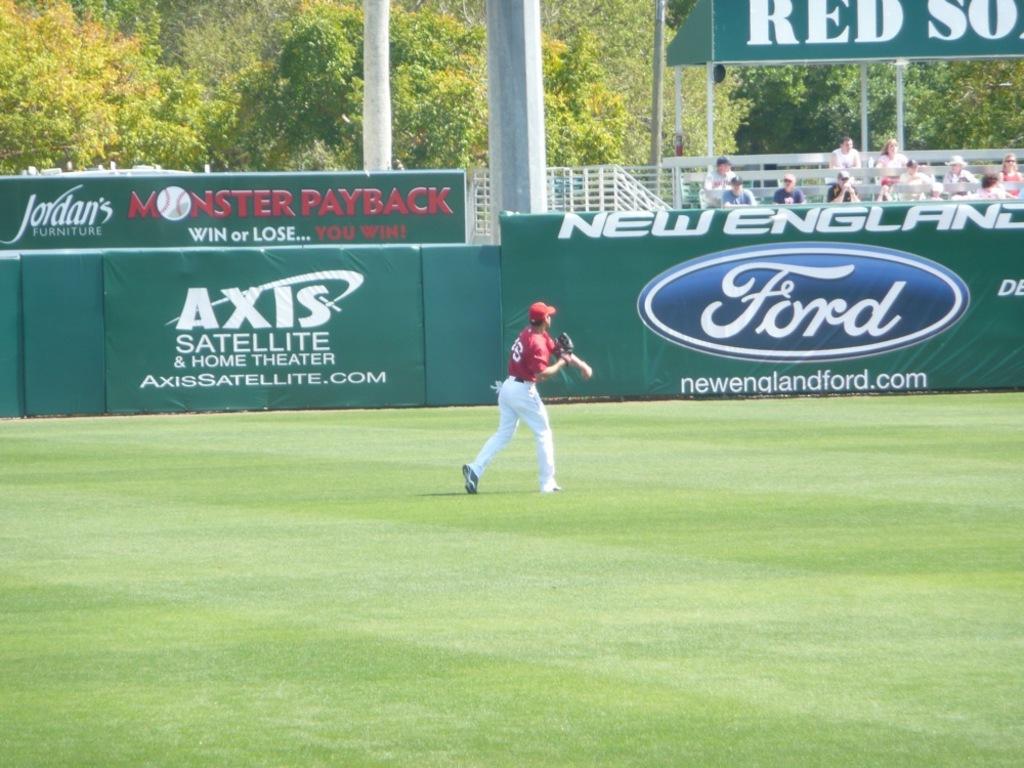What teams are sponsoring this event?
Give a very brief answer. Red sox. What is the website for axis?
Your answer should be very brief. Axissatellite.com. 